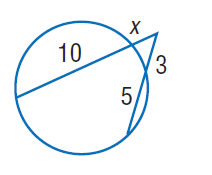Answer the mathemtical geometry problem and directly provide the correct option letter.
Question: Find x. Round to the nearest tenth if necessary.
Choices: A: 2 B: 3 C: 5 D: 10 A 